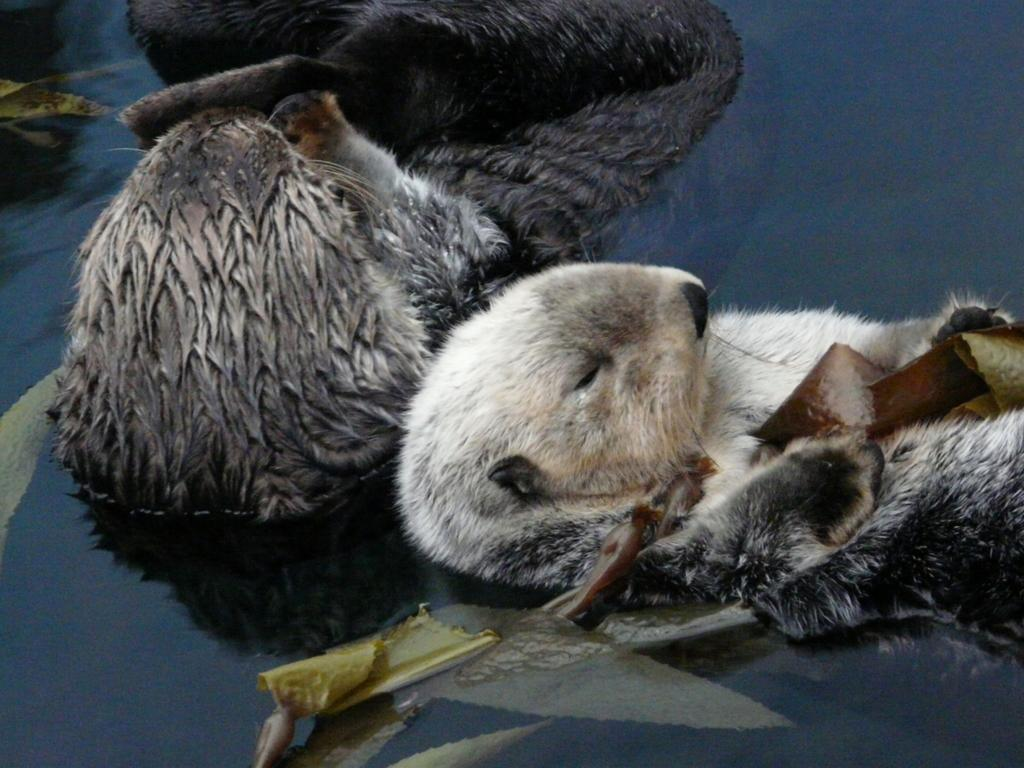How many animals are present in the image? There are two animals in the image. What are the animals doing in the image? The animals are floating on the water. What type of cloth is being used to cover the head of the animals in the image? There is no cloth or head covering visible in the image; the animals are floating on the water without any additional items. 